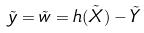Convert formula to latex. <formula><loc_0><loc_0><loc_500><loc_500>\tilde { y } = \tilde { w } = h ( \tilde { X } ) - \tilde { Y }</formula> 